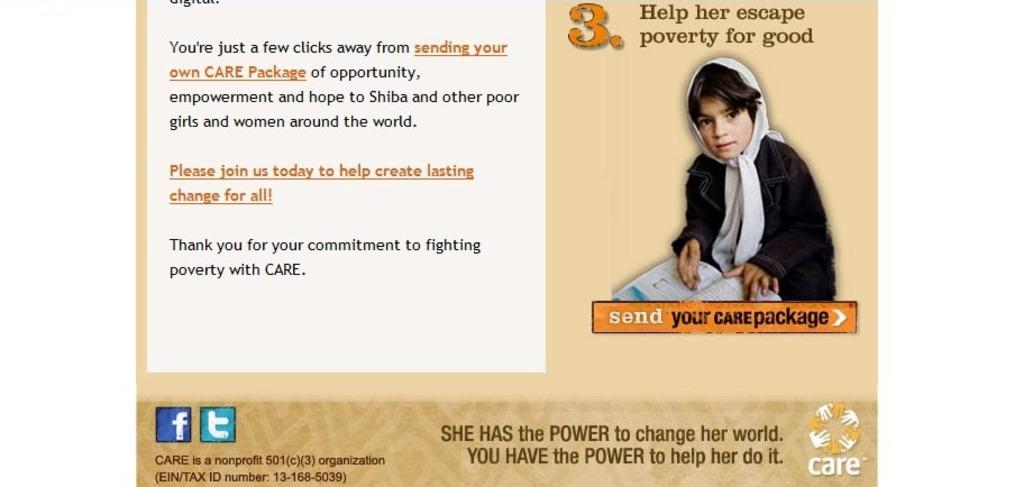What is the main subject of the image? The main subject of the image is a web page. What can be seen within the web page? There is a girl holding a book within the web page. What type of club does the girl's uncle own, as mentioned in the web page? There is no mention of a club or the girl's uncle in the image, so this information cannot be determined. 